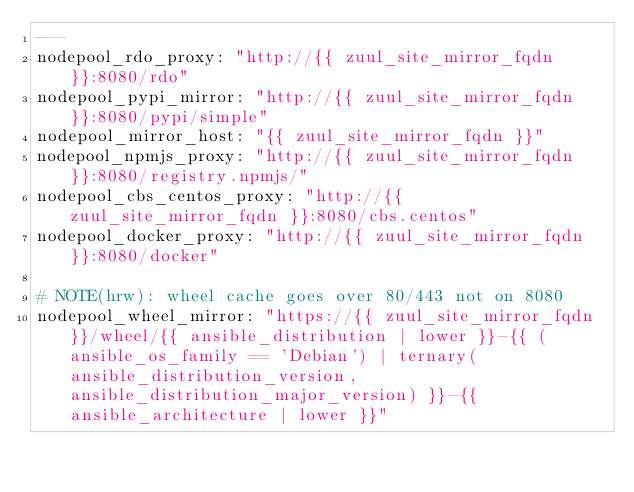<code> <loc_0><loc_0><loc_500><loc_500><_YAML_>---
nodepool_rdo_proxy: "http://{{ zuul_site_mirror_fqdn }}:8080/rdo"
nodepool_pypi_mirror: "http://{{ zuul_site_mirror_fqdn }}:8080/pypi/simple"
nodepool_mirror_host: "{{ zuul_site_mirror_fqdn }}"
nodepool_npmjs_proxy: "http://{{ zuul_site_mirror_fqdn }}:8080/registry.npmjs/"
nodepool_cbs_centos_proxy: "http://{{ zuul_site_mirror_fqdn }}:8080/cbs.centos"
nodepool_docker_proxy: "http://{{ zuul_site_mirror_fqdn }}:8080/docker"

# NOTE(hrw): wheel cache goes over 80/443 not on 8080
nodepool_wheel_mirror: "https://{{ zuul_site_mirror_fqdn }}/wheel/{{ ansible_distribution | lower }}-{{ (ansible_os_family == 'Debian') | ternary(ansible_distribution_version, ansible_distribution_major_version) }}-{{ ansible_architecture | lower }}"
</code> 